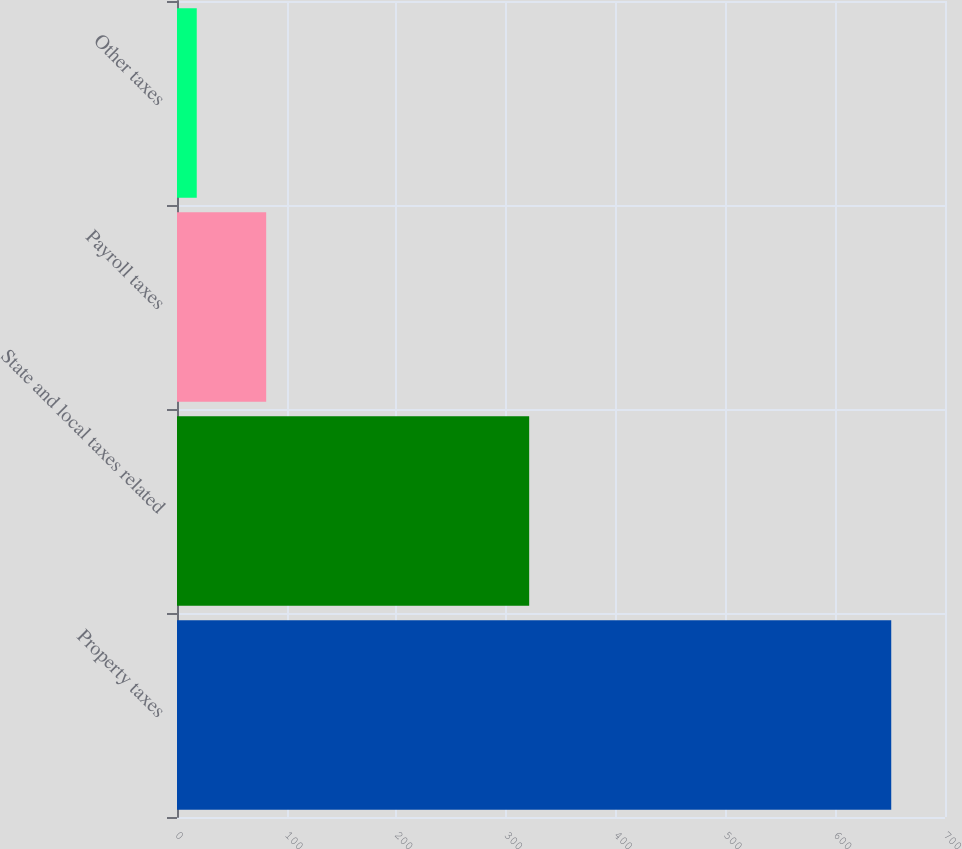Convert chart. <chart><loc_0><loc_0><loc_500><loc_500><bar_chart><fcel>Property taxes<fcel>State and local taxes related<fcel>Payroll taxes<fcel>Other taxes<nl><fcel>651<fcel>321<fcel>81.3<fcel>18<nl></chart> 